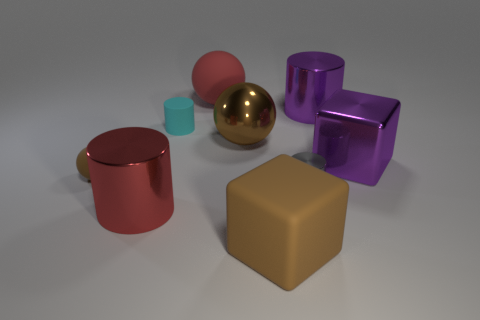Add 1 large red cylinders. How many objects exist? 10 Subtract all red balls. How many purple cubes are left? 1 Subtract all large purple cylinders. Subtract all big metallic cylinders. How many objects are left? 6 Add 1 tiny brown spheres. How many tiny brown spheres are left? 2 Add 3 big blue objects. How many big blue objects exist? 3 Subtract all brown blocks. How many blocks are left? 1 Subtract all brown matte spheres. How many spheres are left? 2 Subtract 0 red blocks. How many objects are left? 9 Subtract all blocks. How many objects are left? 7 Subtract 2 balls. How many balls are left? 1 